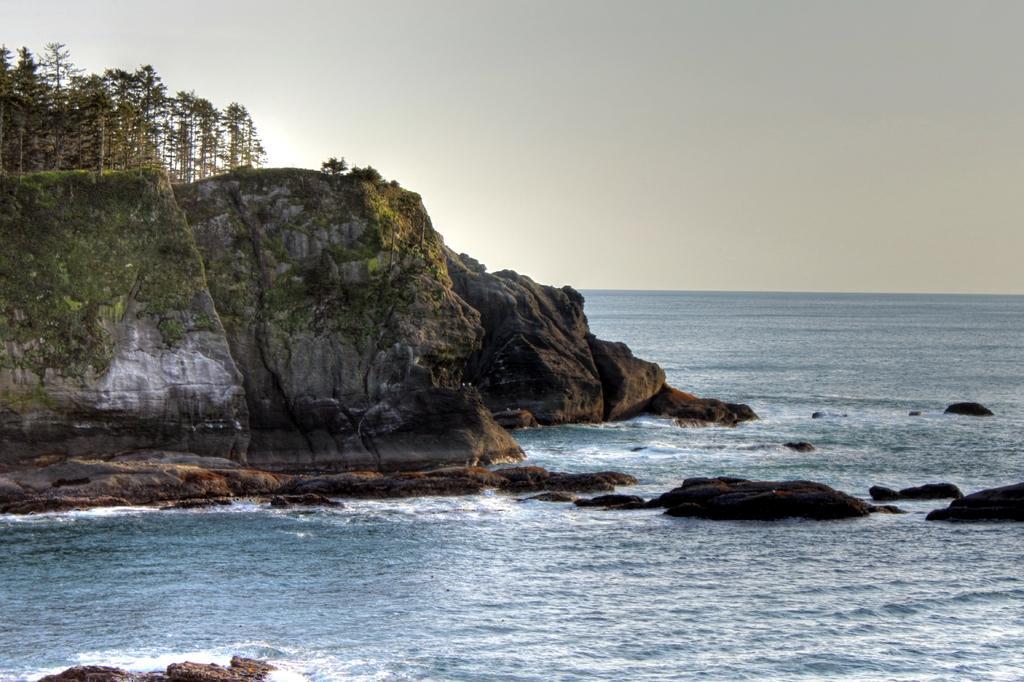Please provide a concise description of this image. In this image we can see a mountain with a group of trees. In the foreground we can see water and in the background, we can see the sky. 